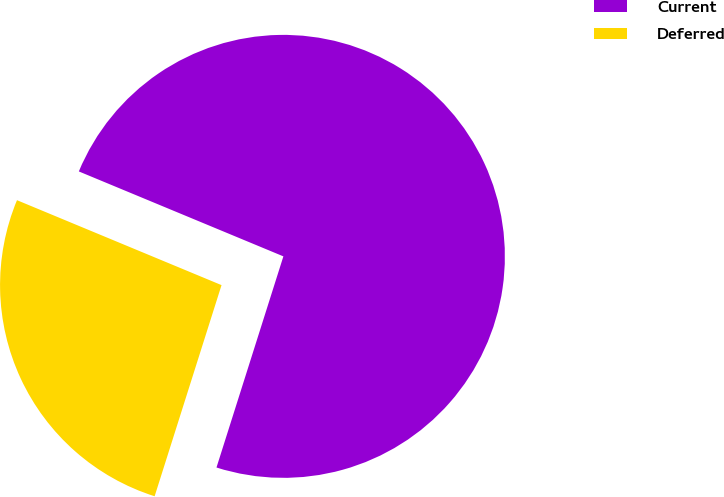Convert chart. <chart><loc_0><loc_0><loc_500><loc_500><pie_chart><fcel>Current<fcel>Deferred<nl><fcel>73.62%<fcel>26.38%<nl></chart> 